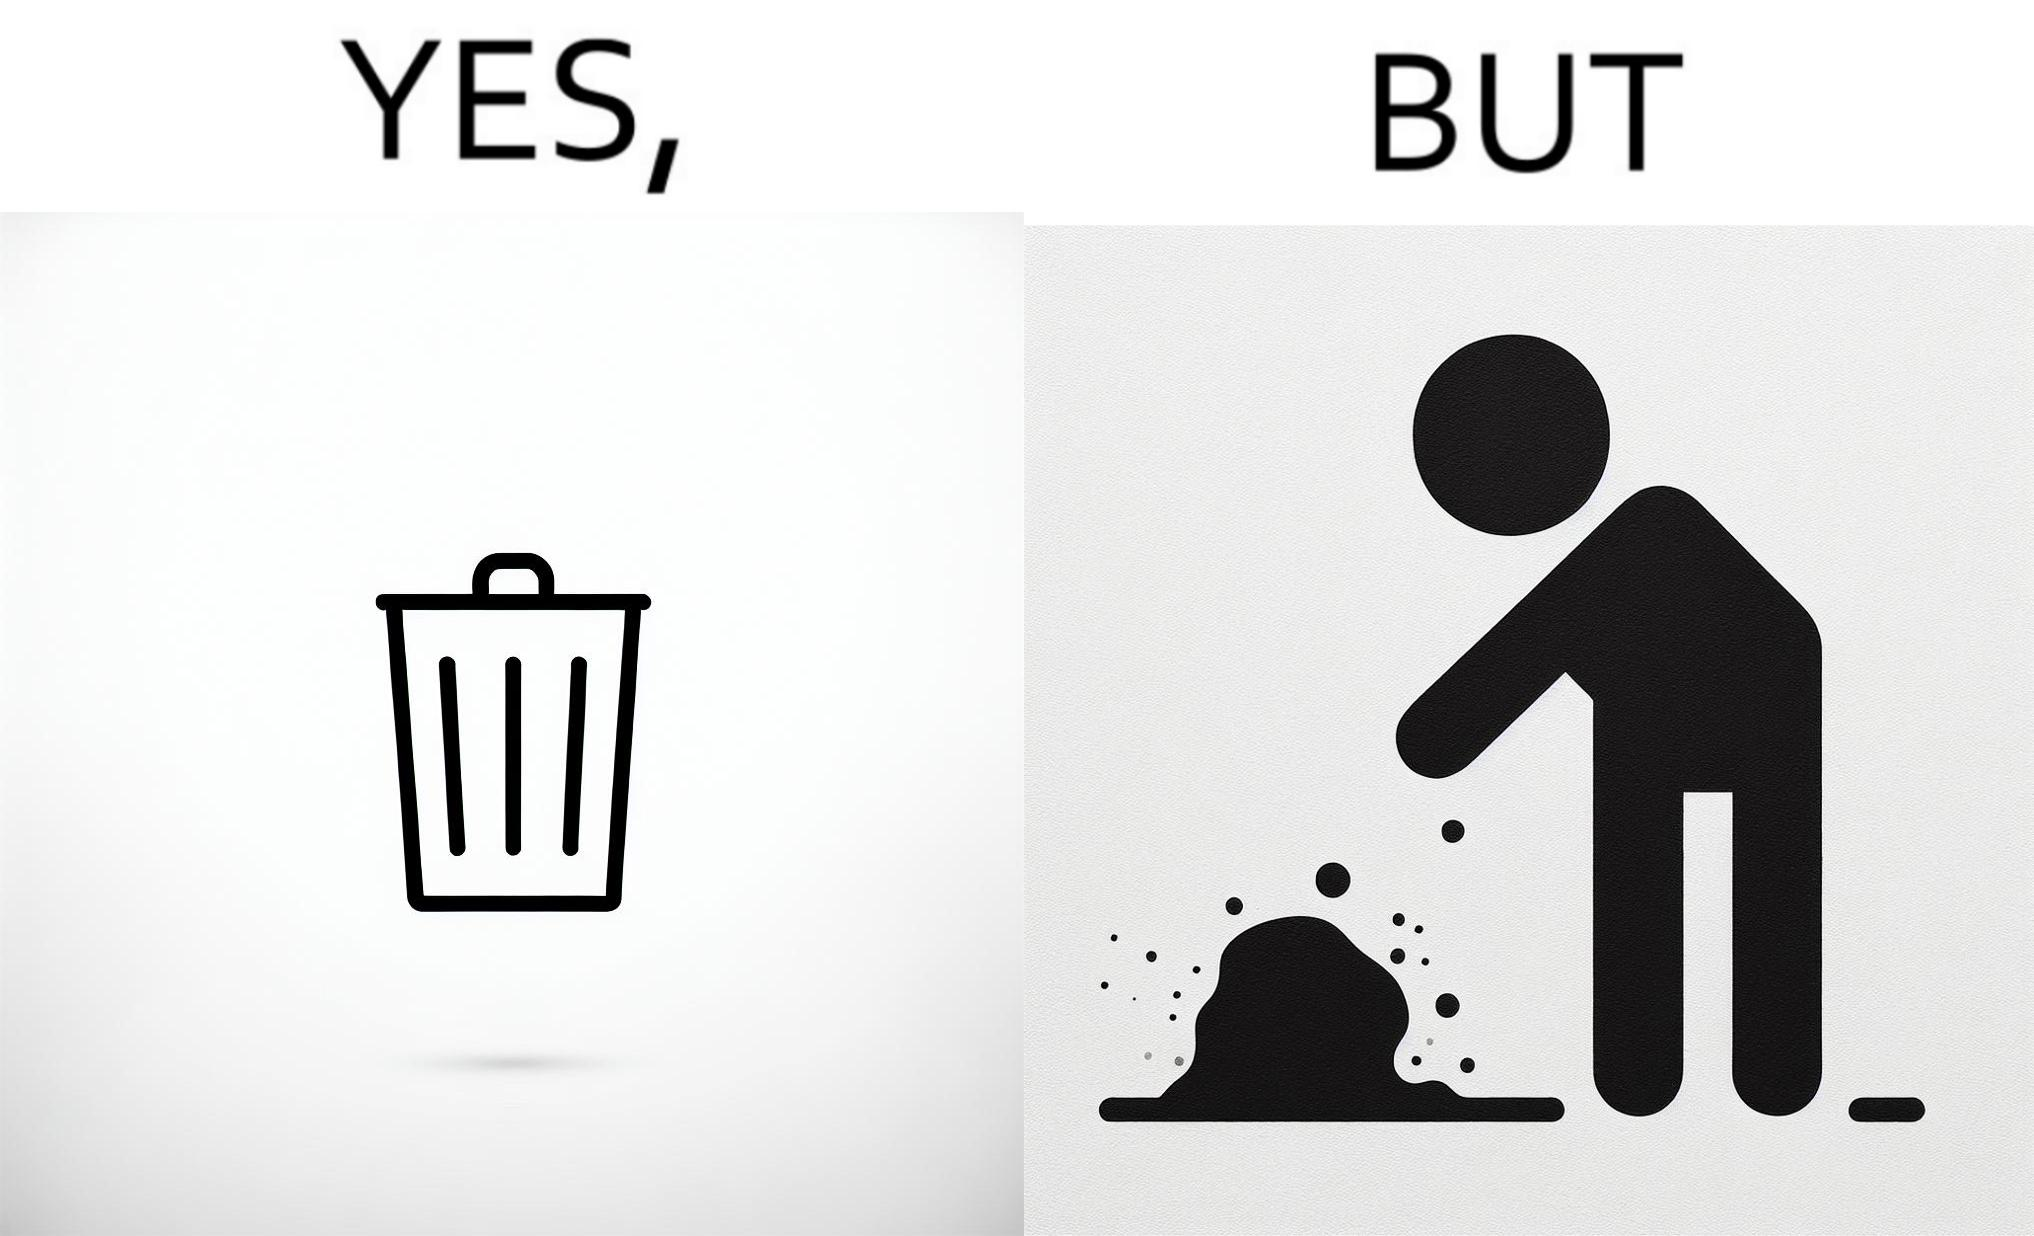Is there satirical content in this image? Yes, this image is satirical. 